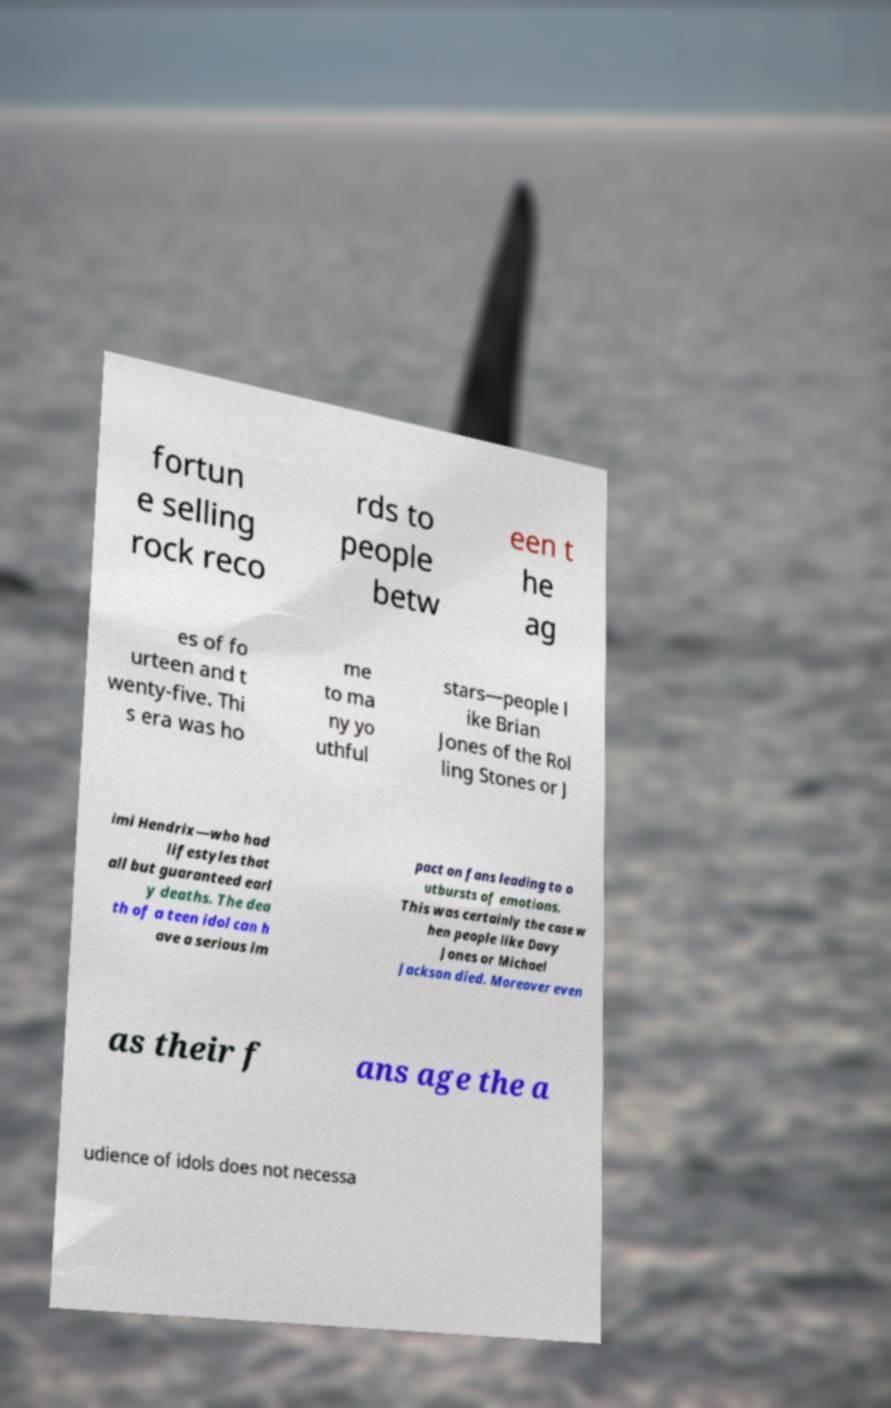Could you assist in decoding the text presented in this image and type it out clearly? fortun e selling rock reco rds to people betw een t he ag es of fo urteen and t wenty-five. Thi s era was ho me to ma ny yo uthful stars—people l ike Brian Jones of the Rol ling Stones or J imi Hendrix—who had lifestyles that all but guaranteed earl y deaths. The dea th of a teen idol can h ave a serious im pact on fans leading to o utbursts of emotions. This was certainly the case w hen people like Davy Jones or Michael Jackson died. Moreover even as their f ans age the a udience of idols does not necessa 